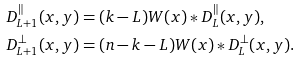<formula> <loc_0><loc_0><loc_500><loc_500>& D _ { L + 1 } ^ { \| } ( x , y ) = ( k - L ) W ( x ) \ast D _ { L } ^ { \| } ( x , y ) , \\ & D _ { L + 1 } ^ { \perp } ( x , y ) = ( n - k - L ) W ( x ) \ast D _ { L } ^ { \perp } ( x , y ) .</formula> 